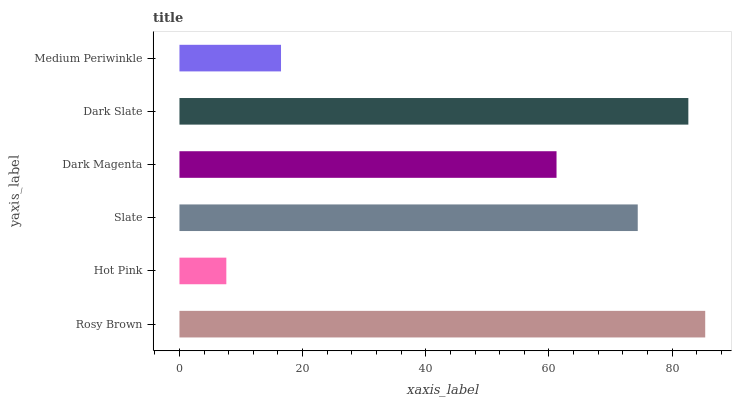Is Hot Pink the minimum?
Answer yes or no. Yes. Is Rosy Brown the maximum?
Answer yes or no. Yes. Is Slate the minimum?
Answer yes or no. No. Is Slate the maximum?
Answer yes or no. No. Is Slate greater than Hot Pink?
Answer yes or no. Yes. Is Hot Pink less than Slate?
Answer yes or no. Yes. Is Hot Pink greater than Slate?
Answer yes or no. No. Is Slate less than Hot Pink?
Answer yes or no. No. Is Slate the high median?
Answer yes or no. Yes. Is Dark Magenta the low median?
Answer yes or no. Yes. Is Dark Slate the high median?
Answer yes or no. No. Is Hot Pink the low median?
Answer yes or no. No. 